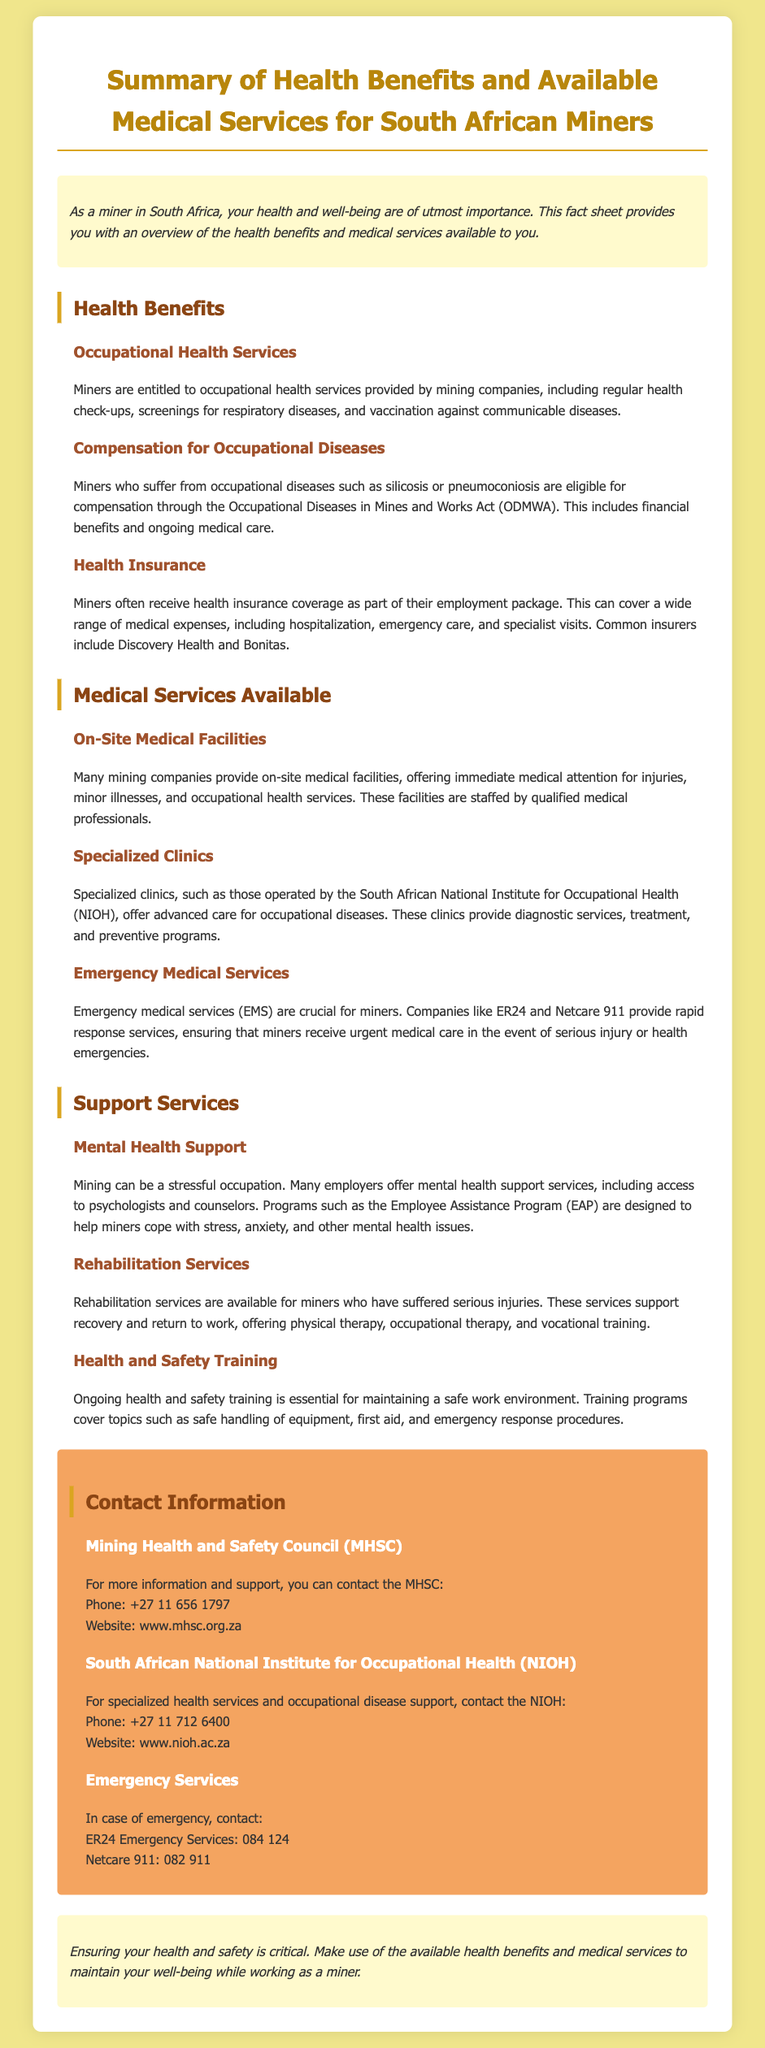What are miners entitled to under occupational health services? Miners are entitled to occupational health services provided by mining companies, including regular health check-ups, screenings for respiratory diseases, and vaccination against communicable diseases.
Answer: Occupational health services What act provides compensation for occupational diseases? The Occupational Diseases in Mines and Works Act (ODMWA) provides compensation for miners suffering from occupational diseases.
Answer: ODMWA What kind of health insurance do miners often receive? Miners often receive health insurance coverage as part of their employment package that covers a range of medical expenses.
Answer: Health insurance coverage Which organization operates specialized clinics for miners? The South African National Institute for Occupational Health (NIOH) operates specialized clinics for miners.
Answer: NIOH What emergency medical service is mentioned for miners? Companies like ER24 and Netcare 911 provide emergency medical services for miners.
Answer: ER24 and Netcare 911 What mental health support is offered to miners? Many employers offer mental health support services, including access to psychologists and counselors.
Answer: Psychologists and counselors How can miners contact the Mining Health and Safety Council? Miners can contact the Mining Health and Safety Council (MHSC) via phone or their website.
Answer: Phone: +27 11 656 1797 What is a critical aspect of ensuring miner health and safety? Ensuring health and safety is critical and involves making use of available health benefits and medical services.
Answer: Use of health benefits and services 